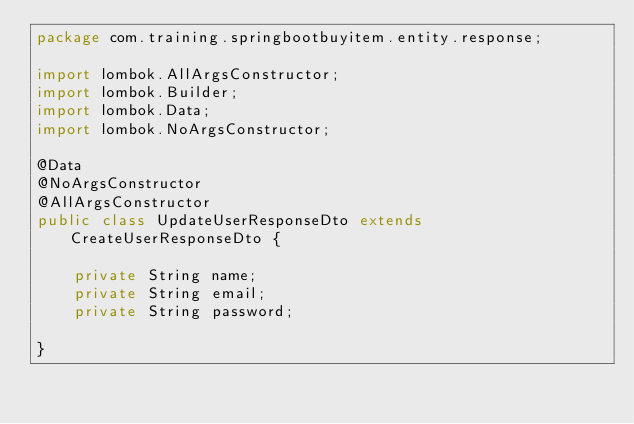Convert code to text. <code><loc_0><loc_0><loc_500><loc_500><_Java_>package com.training.springbootbuyitem.entity.response;

import lombok.AllArgsConstructor;
import lombok.Builder;
import lombok.Data;
import lombok.NoArgsConstructor;

@Data
@NoArgsConstructor
@AllArgsConstructor
public class UpdateUserResponseDto extends CreateUserResponseDto {

    private String name;
    private String email;
    private String password;

}
</code> 